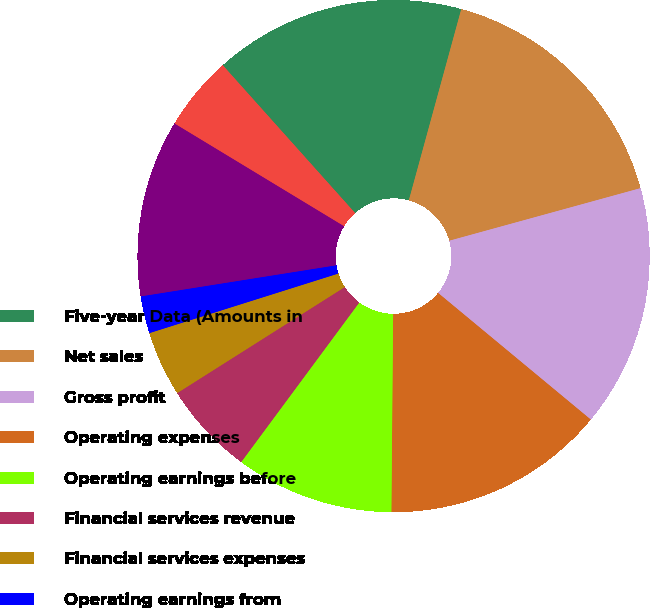Convert chart. <chart><loc_0><loc_0><loc_500><loc_500><pie_chart><fcel>Five-year Data (Amounts in<fcel>Net sales<fcel>Gross profit<fcel>Operating expenses<fcel>Operating earnings before<fcel>Financial services revenue<fcel>Financial services expenses<fcel>Operating earnings from<fcel>Operating earnings<fcel>Interest expense<nl><fcel>15.88%<fcel>16.47%<fcel>15.29%<fcel>14.12%<fcel>10.0%<fcel>5.88%<fcel>4.12%<fcel>2.35%<fcel>11.18%<fcel>4.71%<nl></chart> 